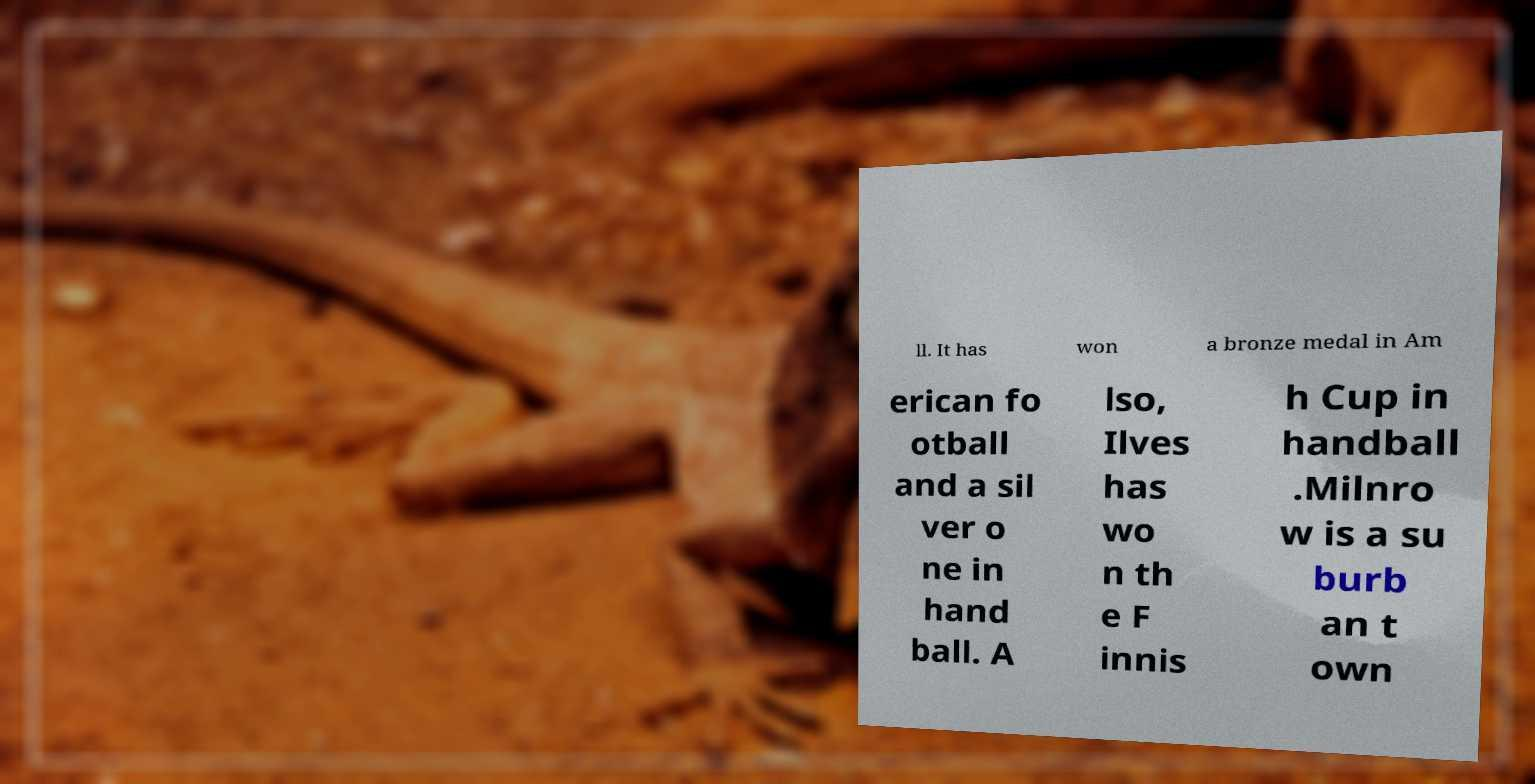Could you assist in decoding the text presented in this image and type it out clearly? ll. It has won a bronze medal in Am erican fo otball and a sil ver o ne in hand ball. A lso, Ilves has wo n th e F innis h Cup in handball .Milnro w is a su burb an t own 